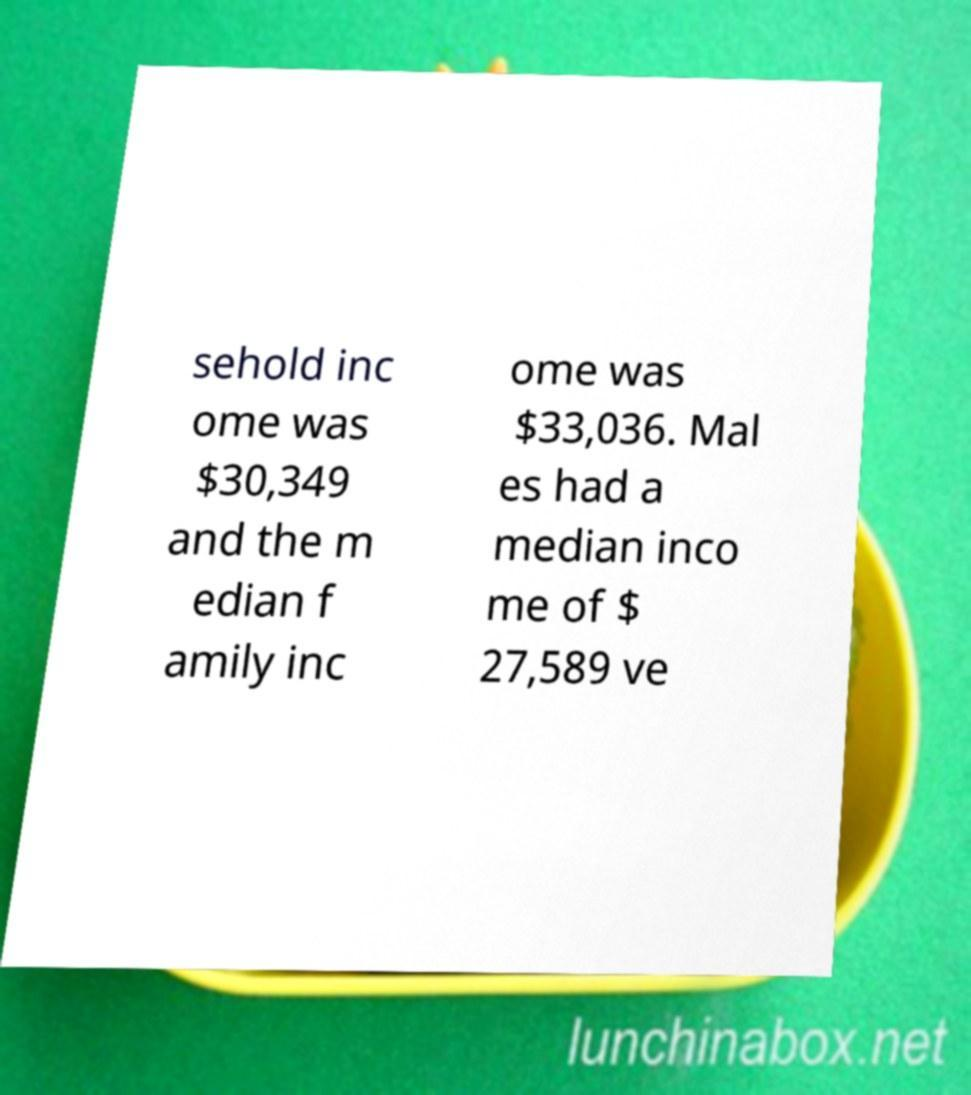Can you accurately transcribe the text from the provided image for me? sehold inc ome was $30,349 and the m edian f amily inc ome was $33,036. Mal es had a median inco me of $ 27,589 ve 